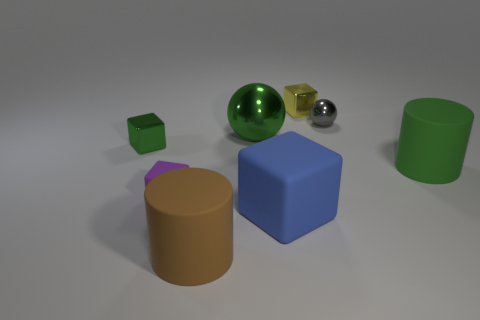Add 1 big metal balls. How many objects exist? 9 Subtract all green balls. Subtract all green cylinders. How many balls are left? 1 Subtract all spheres. How many objects are left? 6 Subtract 1 brown cylinders. How many objects are left? 7 Subtract all large blue matte objects. Subtract all small gray metallic objects. How many objects are left? 6 Add 2 purple matte things. How many purple matte things are left? 3 Add 7 gray metallic spheres. How many gray metallic spheres exist? 8 